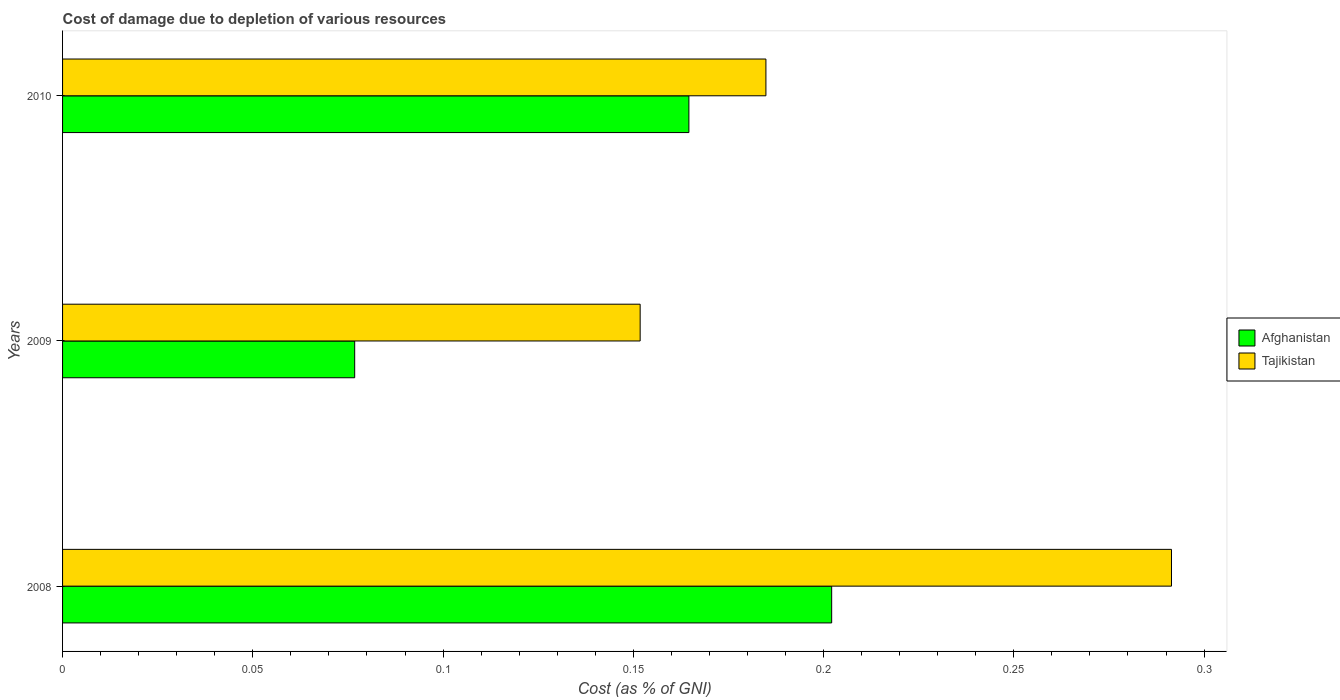How many groups of bars are there?
Provide a succinct answer. 3. Are the number of bars on each tick of the Y-axis equal?
Give a very brief answer. Yes. How many bars are there on the 2nd tick from the bottom?
Offer a terse response. 2. In how many cases, is the number of bars for a given year not equal to the number of legend labels?
Your response must be concise. 0. What is the cost of damage caused due to the depletion of various resources in Afghanistan in 2008?
Your answer should be compact. 0.2. Across all years, what is the maximum cost of damage caused due to the depletion of various resources in Tajikistan?
Provide a succinct answer. 0.29. Across all years, what is the minimum cost of damage caused due to the depletion of various resources in Afghanistan?
Offer a very short reply. 0.08. In which year was the cost of damage caused due to the depletion of various resources in Afghanistan maximum?
Provide a short and direct response. 2008. What is the total cost of damage caused due to the depletion of various resources in Afghanistan in the graph?
Provide a short and direct response. 0.44. What is the difference between the cost of damage caused due to the depletion of various resources in Tajikistan in 2008 and that in 2010?
Ensure brevity in your answer.  0.11. What is the difference between the cost of damage caused due to the depletion of various resources in Tajikistan in 2010 and the cost of damage caused due to the depletion of various resources in Afghanistan in 2009?
Your response must be concise. 0.11. What is the average cost of damage caused due to the depletion of various resources in Afghanistan per year?
Your answer should be compact. 0.15. In the year 2008, what is the difference between the cost of damage caused due to the depletion of various resources in Tajikistan and cost of damage caused due to the depletion of various resources in Afghanistan?
Keep it short and to the point. 0.09. What is the ratio of the cost of damage caused due to the depletion of various resources in Tajikistan in 2008 to that in 2009?
Offer a terse response. 1.92. What is the difference between the highest and the second highest cost of damage caused due to the depletion of various resources in Tajikistan?
Your response must be concise. 0.11. What is the difference between the highest and the lowest cost of damage caused due to the depletion of various resources in Afghanistan?
Your answer should be compact. 0.13. In how many years, is the cost of damage caused due to the depletion of various resources in Tajikistan greater than the average cost of damage caused due to the depletion of various resources in Tajikistan taken over all years?
Ensure brevity in your answer.  1. Is the sum of the cost of damage caused due to the depletion of various resources in Afghanistan in 2009 and 2010 greater than the maximum cost of damage caused due to the depletion of various resources in Tajikistan across all years?
Your answer should be very brief. No. What does the 1st bar from the top in 2010 represents?
Your response must be concise. Tajikistan. What does the 1st bar from the bottom in 2008 represents?
Provide a short and direct response. Afghanistan. How many bars are there?
Offer a very short reply. 6. What is the difference between two consecutive major ticks on the X-axis?
Offer a terse response. 0.05. Are the values on the major ticks of X-axis written in scientific E-notation?
Your answer should be compact. No. Does the graph contain grids?
Make the answer very short. No. How many legend labels are there?
Offer a very short reply. 2. How are the legend labels stacked?
Make the answer very short. Vertical. What is the title of the graph?
Your answer should be compact. Cost of damage due to depletion of various resources. Does "France" appear as one of the legend labels in the graph?
Make the answer very short. No. What is the label or title of the X-axis?
Keep it short and to the point. Cost (as % of GNI). What is the Cost (as % of GNI) in Afghanistan in 2008?
Give a very brief answer. 0.2. What is the Cost (as % of GNI) in Tajikistan in 2008?
Your response must be concise. 0.29. What is the Cost (as % of GNI) of Afghanistan in 2009?
Provide a short and direct response. 0.08. What is the Cost (as % of GNI) in Tajikistan in 2009?
Make the answer very short. 0.15. What is the Cost (as % of GNI) of Afghanistan in 2010?
Give a very brief answer. 0.16. What is the Cost (as % of GNI) of Tajikistan in 2010?
Your answer should be very brief. 0.18. Across all years, what is the maximum Cost (as % of GNI) of Afghanistan?
Make the answer very short. 0.2. Across all years, what is the maximum Cost (as % of GNI) of Tajikistan?
Keep it short and to the point. 0.29. Across all years, what is the minimum Cost (as % of GNI) of Afghanistan?
Give a very brief answer. 0.08. Across all years, what is the minimum Cost (as % of GNI) of Tajikistan?
Offer a terse response. 0.15. What is the total Cost (as % of GNI) in Afghanistan in the graph?
Keep it short and to the point. 0.44. What is the total Cost (as % of GNI) of Tajikistan in the graph?
Give a very brief answer. 0.63. What is the difference between the Cost (as % of GNI) in Afghanistan in 2008 and that in 2009?
Your answer should be compact. 0.13. What is the difference between the Cost (as % of GNI) of Tajikistan in 2008 and that in 2009?
Your response must be concise. 0.14. What is the difference between the Cost (as % of GNI) of Afghanistan in 2008 and that in 2010?
Provide a short and direct response. 0.04. What is the difference between the Cost (as % of GNI) of Tajikistan in 2008 and that in 2010?
Offer a very short reply. 0.11. What is the difference between the Cost (as % of GNI) in Afghanistan in 2009 and that in 2010?
Your answer should be very brief. -0.09. What is the difference between the Cost (as % of GNI) in Tajikistan in 2009 and that in 2010?
Give a very brief answer. -0.03. What is the difference between the Cost (as % of GNI) of Afghanistan in 2008 and the Cost (as % of GNI) of Tajikistan in 2009?
Provide a short and direct response. 0.05. What is the difference between the Cost (as % of GNI) of Afghanistan in 2008 and the Cost (as % of GNI) of Tajikistan in 2010?
Your answer should be very brief. 0.02. What is the difference between the Cost (as % of GNI) in Afghanistan in 2009 and the Cost (as % of GNI) in Tajikistan in 2010?
Your response must be concise. -0.11. What is the average Cost (as % of GNI) in Afghanistan per year?
Make the answer very short. 0.15. What is the average Cost (as % of GNI) in Tajikistan per year?
Keep it short and to the point. 0.21. In the year 2008, what is the difference between the Cost (as % of GNI) in Afghanistan and Cost (as % of GNI) in Tajikistan?
Ensure brevity in your answer.  -0.09. In the year 2009, what is the difference between the Cost (as % of GNI) of Afghanistan and Cost (as % of GNI) of Tajikistan?
Keep it short and to the point. -0.07. In the year 2010, what is the difference between the Cost (as % of GNI) in Afghanistan and Cost (as % of GNI) in Tajikistan?
Ensure brevity in your answer.  -0.02. What is the ratio of the Cost (as % of GNI) in Afghanistan in 2008 to that in 2009?
Give a very brief answer. 2.63. What is the ratio of the Cost (as % of GNI) of Tajikistan in 2008 to that in 2009?
Keep it short and to the point. 1.92. What is the ratio of the Cost (as % of GNI) in Afghanistan in 2008 to that in 2010?
Make the answer very short. 1.23. What is the ratio of the Cost (as % of GNI) of Tajikistan in 2008 to that in 2010?
Ensure brevity in your answer.  1.58. What is the ratio of the Cost (as % of GNI) of Afghanistan in 2009 to that in 2010?
Offer a very short reply. 0.47. What is the ratio of the Cost (as % of GNI) in Tajikistan in 2009 to that in 2010?
Provide a short and direct response. 0.82. What is the difference between the highest and the second highest Cost (as % of GNI) of Afghanistan?
Provide a succinct answer. 0.04. What is the difference between the highest and the second highest Cost (as % of GNI) of Tajikistan?
Ensure brevity in your answer.  0.11. What is the difference between the highest and the lowest Cost (as % of GNI) in Afghanistan?
Your answer should be compact. 0.13. What is the difference between the highest and the lowest Cost (as % of GNI) in Tajikistan?
Provide a succinct answer. 0.14. 